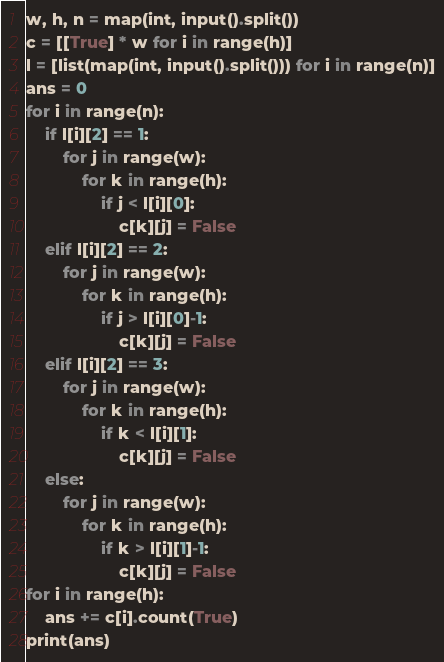<code> <loc_0><loc_0><loc_500><loc_500><_Python_>w, h, n = map(int, input().split())
c = [[True] * w for i in range(h)]
l = [list(map(int, input().split())) for i in range(n)]
ans = 0
for i in range(n):
    if l[i][2] == 1:
        for j in range(w):
            for k in range(h):
                if j < l[i][0]:
                    c[k][j] = False
    elif l[i][2] == 2:
        for j in range(w):
            for k in range(h):
                if j > l[i][0]-1:
                    c[k][j] = False
    elif l[i][2] == 3:
        for j in range(w):
            for k in range(h):
                if k < l[i][1]:
                    c[k][j] = False
    else:
        for j in range(w):
            for k in range(h):
                if k > l[i][1]-1:
                    c[k][j] = False
for i in range(h):
    ans += c[i].count(True)
print(ans)</code> 